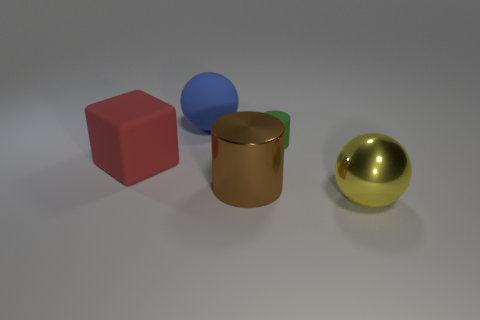Do the shiny object to the right of the brown metal object and the green cylinder have the same size?
Keep it short and to the point. No. What number of things are either objects that are in front of the blue rubber sphere or large red shiny balls?
Offer a terse response. 4. Is there a yellow object that has the same size as the red matte object?
Ensure brevity in your answer.  Yes. There is another ball that is the same size as the metallic sphere; what is its material?
Provide a short and direct response. Rubber. The big object that is both on the left side of the yellow shiny ball and in front of the block has what shape?
Make the answer very short. Cylinder. The big ball that is behind the red rubber thing is what color?
Keep it short and to the point. Blue. How big is the rubber object that is both left of the brown shiny thing and in front of the matte ball?
Provide a succinct answer. Large. Is the material of the big blue ball the same as the cylinder behind the big red matte thing?
Provide a succinct answer. Yes. How many other objects are the same shape as the large brown object?
Offer a terse response. 1. How many small red metal spheres are there?
Provide a short and direct response. 0. 